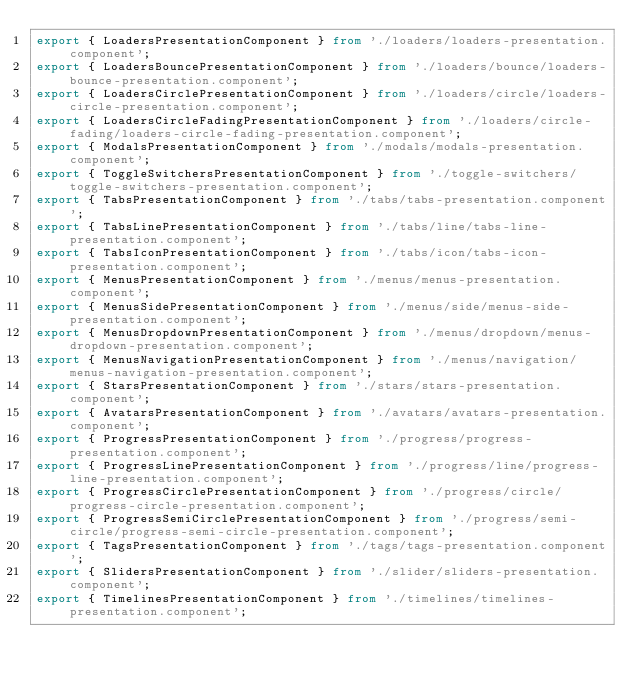<code> <loc_0><loc_0><loc_500><loc_500><_TypeScript_>export { LoadersPresentationComponent } from './loaders/loaders-presentation.component';
export { LoadersBouncePresentationComponent } from './loaders/bounce/loaders-bounce-presentation.component';
export { LoadersCirclePresentationComponent } from './loaders/circle/loaders-circle-presentation.component';
export { LoadersCircleFadingPresentationComponent } from './loaders/circle-fading/loaders-circle-fading-presentation.component';
export { ModalsPresentationComponent } from './modals/modals-presentation.component';
export { ToggleSwitchersPresentationComponent } from './toggle-switchers/toggle-switchers-presentation.component';
export { TabsPresentationComponent } from './tabs/tabs-presentation.component';
export { TabsLinePresentationComponent } from './tabs/line/tabs-line-presentation.component';
export { TabsIconPresentationComponent } from './tabs/icon/tabs-icon-presentation.component';
export { MenusPresentationComponent } from './menus/menus-presentation.component';
export { MenusSidePresentationComponent } from './menus/side/menus-side-presentation.component';
export { MenusDropdownPresentationComponent } from './menus/dropdown/menus-dropdown-presentation.component';
export { MenusNavigationPresentationComponent } from './menus/navigation/menus-navigation-presentation.component';
export { StarsPresentationComponent } from './stars/stars-presentation.component';
export { AvatarsPresentationComponent } from './avatars/avatars-presentation.component';
export { ProgressPresentationComponent } from './progress/progress-presentation.component';
export { ProgressLinePresentationComponent } from './progress/line/progress-line-presentation.component';
export { ProgressCirclePresentationComponent } from './progress/circle/progress-circle-presentation.component';
export { ProgressSemiCirclePresentationComponent } from './progress/semi-circle/progress-semi-circle-presentation.component';
export { TagsPresentationComponent } from './tags/tags-presentation.component';
export { SlidersPresentationComponent } from './slider/sliders-presentation.component';
export { TimelinesPresentationComponent } from './timelines/timelines-presentation.component';</code> 